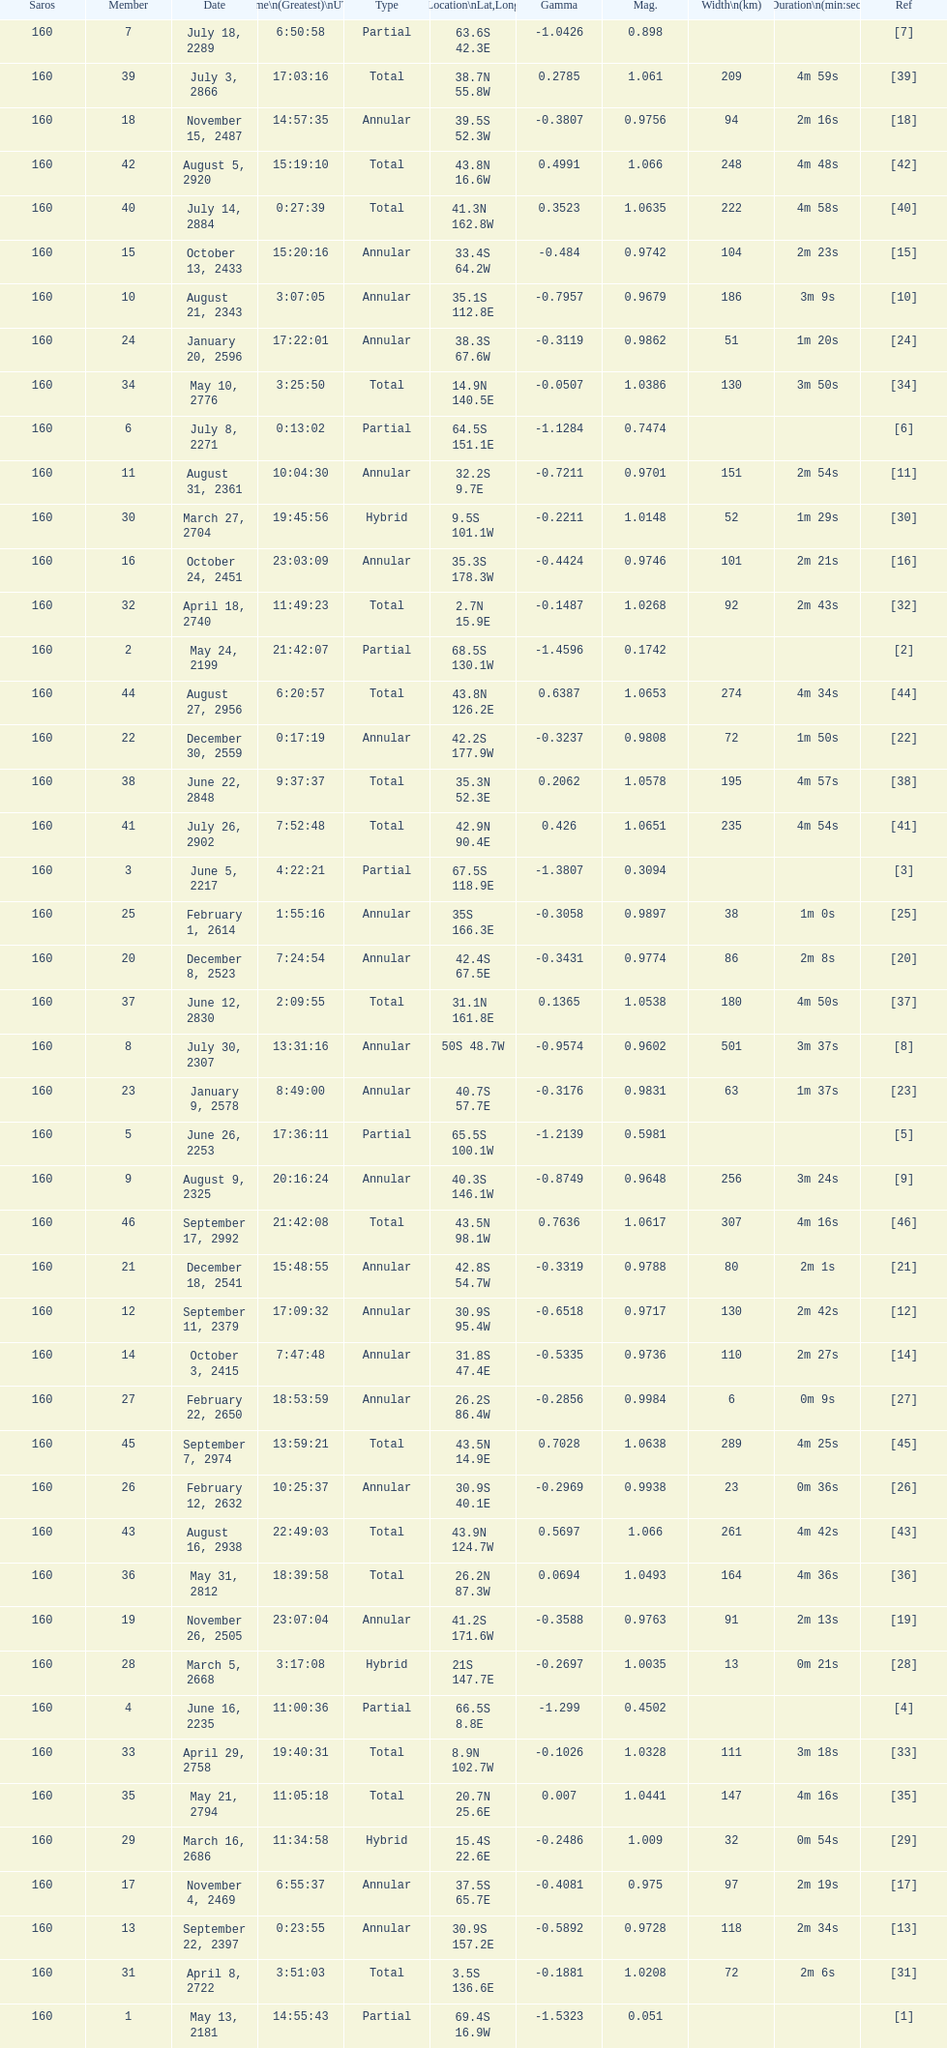Name a member number with a latitude above 60 s. 1. Parse the table in full. {'header': ['Saros', 'Member', 'Date', 'Time\\n(Greatest)\\nUTC', 'Type', 'Location\\nLat,Long', 'Gamma', 'Mag.', 'Width\\n(km)', 'Duration\\n(min:sec)', 'Ref'], 'rows': [['160', '7', 'July 18, 2289', '6:50:58', 'Partial', '63.6S 42.3E', '-1.0426', '0.898', '', '', '[7]'], ['160', '39', 'July 3, 2866', '17:03:16', 'Total', '38.7N 55.8W', '0.2785', '1.061', '209', '4m 59s', '[39]'], ['160', '18', 'November 15, 2487', '14:57:35', 'Annular', '39.5S 52.3W', '-0.3807', '0.9756', '94', '2m 16s', '[18]'], ['160', '42', 'August 5, 2920', '15:19:10', 'Total', '43.8N 16.6W', '0.4991', '1.066', '248', '4m 48s', '[42]'], ['160', '40', 'July 14, 2884', '0:27:39', 'Total', '41.3N 162.8W', '0.3523', '1.0635', '222', '4m 58s', '[40]'], ['160', '15', 'October 13, 2433', '15:20:16', 'Annular', '33.4S 64.2W', '-0.484', '0.9742', '104', '2m 23s', '[15]'], ['160', '10', 'August 21, 2343', '3:07:05', 'Annular', '35.1S 112.8E', '-0.7957', '0.9679', '186', '3m 9s', '[10]'], ['160', '24', 'January 20, 2596', '17:22:01', 'Annular', '38.3S 67.6W', '-0.3119', '0.9862', '51', '1m 20s', '[24]'], ['160', '34', 'May 10, 2776', '3:25:50', 'Total', '14.9N 140.5E', '-0.0507', '1.0386', '130', '3m 50s', '[34]'], ['160', '6', 'July 8, 2271', '0:13:02', 'Partial', '64.5S 151.1E', '-1.1284', '0.7474', '', '', '[6]'], ['160', '11', 'August 31, 2361', '10:04:30', 'Annular', '32.2S 9.7E', '-0.7211', '0.9701', '151', '2m 54s', '[11]'], ['160', '30', 'March 27, 2704', '19:45:56', 'Hybrid', '9.5S 101.1W', '-0.2211', '1.0148', '52', '1m 29s', '[30]'], ['160', '16', 'October 24, 2451', '23:03:09', 'Annular', '35.3S 178.3W', '-0.4424', '0.9746', '101', '2m 21s', '[16]'], ['160', '32', 'April 18, 2740', '11:49:23', 'Total', '2.7N 15.9E', '-0.1487', '1.0268', '92', '2m 43s', '[32]'], ['160', '2', 'May 24, 2199', '21:42:07', 'Partial', '68.5S 130.1W', '-1.4596', '0.1742', '', '', '[2]'], ['160', '44', 'August 27, 2956', '6:20:57', 'Total', '43.8N 126.2E', '0.6387', '1.0653', '274', '4m 34s', '[44]'], ['160', '22', 'December 30, 2559', '0:17:19', 'Annular', '42.2S 177.9W', '-0.3237', '0.9808', '72', '1m 50s', '[22]'], ['160', '38', 'June 22, 2848', '9:37:37', 'Total', '35.3N 52.3E', '0.2062', '1.0578', '195', '4m 57s', '[38]'], ['160', '41', 'July 26, 2902', '7:52:48', 'Total', '42.9N 90.4E', '0.426', '1.0651', '235', '4m 54s', '[41]'], ['160', '3', 'June 5, 2217', '4:22:21', 'Partial', '67.5S 118.9E', '-1.3807', '0.3094', '', '', '[3]'], ['160', '25', 'February 1, 2614', '1:55:16', 'Annular', '35S 166.3E', '-0.3058', '0.9897', '38', '1m 0s', '[25]'], ['160', '20', 'December 8, 2523', '7:24:54', 'Annular', '42.4S 67.5E', '-0.3431', '0.9774', '86', '2m 8s', '[20]'], ['160', '37', 'June 12, 2830', '2:09:55', 'Total', '31.1N 161.8E', '0.1365', '1.0538', '180', '4m 50s', '[37]'], ['160', '8', 'July 30, 2307', '13:31:16', 'Annular', '50S 48.7W', '-0.9574', '0.9602', '501', '3m 37s', '[8]'], ['160', '23', 'January 9, 2578', '8:49:00', 'Annular', '40.7S 57.7E', '-0.3176', '0.9831', '63', '1m 37s', '[23]'], ['160', '5', 'June 26, 2253', '17:36:11', 'Partial', '65.5S 100.1W', '-1.2139', '0.5981', '', '', '[5]'], ['160', '9', 'August 9, 2325', '20:16:24', 'Annular', '40.3S 146.1W', '-0.8749', '0.9648', '256', '3m 24s', '[9]'], ['160', '46', 'September 17, 2992', '21:42:08', 'Total', '43.5N 98.1W', '0.7636', '1.0617', '307', '4m 16s', '[46]'], ['160', '21', 'December 18, 2541', '15:48:55', 'Annular', '42.8S 54.7W', '-0.3319', '0.9788', '80', '2m 1s', '[21]'], ['160', '12', 'September 11, 2379', '17:09:32', 'Annular', '30.9S 95.4W', '-0.6518', '0.9717', '130', '2m 42s', '[12]'], ['160', '14', 'October 3, 2415', '7:47:48', 'Annular', '31.8S 47.4E', '-0.5335', '0.9736', '110', '2m 27s', '[14]'], ['160', '27', 'February 22, 2650', '18:53:59', 'Annular', '26.2S 86.4W', '-0.2856', '0.9984', '6', '0m 9s', '[27]'], ['160', '45', 'September 7, 2974', '13:59:21', 'Total', '43.5N 14.9E', '0.7028', '1.0638', '289', '4m 25s', '[45]'], ['160', '26', 'February 12, 2632', '10:25:37', 'Annular', '30.9S 40.1E', '-0.2969', '0.9938', '23', '0m 36s', '[26]'], ['160', '43', 'August 16, 2938', '22:49:03', 'Total', '43.9N 124.7W', '0.5697', '1.066', '261', '4m 42s', '[43]'], ['160', '36', 'May 31, 2812', '18:39:58', 'Total', '26.2N 87.3W', '0.0694', '1.0493', '164', '4m 36s', '[36]'], ['160', '19', 'November 26, 2505', '23:07:04', 'Annular', '41.2S 171.6W', '-0.3588', '0.9763', '91', '2m 13s', '[19]'], ['160', '28', 'March 5, 2668', '3:17:08', 'Hybrid', '21S 147.7E', '-0.2697', '1.0035', '13', '0m 21s', '[28]'], ['160', '4', 'June 16, 2235', '11:00:36', 'Partial', '66.5S 8.8E', '-1.299', '0.4502', '', '', '[4]'], ['160', '33', 'April 29, 2758', '19:40:31', 'Total', '8.9N 102.7W', '-0.1026', '1.0328', '111', '3m 18s', '[33]'], ['160', '35', 'May 21, 2794', '11:05:18', 'Total', '20.7N 25.6E', '0.007', '1.0441', '147', '4m 16s', '[35]'], ['160', '29', 'March 16, 2686', '11:34:58', 'Hybrid', '15.4S 22.6E', '-0.2486', '1.009', '32', '0m 54s', '[29]'], ['160', '17', 'November 4, 2469', '6:55:37', 'Annular', '37.5S 65.7E', '-0.4081', '0.975', '97', '2m 19s', '[17]'], ['160', '13', 'September 22, 2397', '0:23:55', 'Annular', '30.9S 157.2E', '-0.5892', '0.9728', '118', '2m 34s', '[13]'], ['160', '31', 'April 8, 2722', '3:51:03', 'Total', '3.5S 136.6E', '-0.1881', '1.0208', '72', '2m 6s', '[31]'], ['160', '1', 'May 13, 2181', '14:55:43', 'Partial', '69.4S 16.9W', '-1.5323', '0.051', '', '', '[1]']]} 